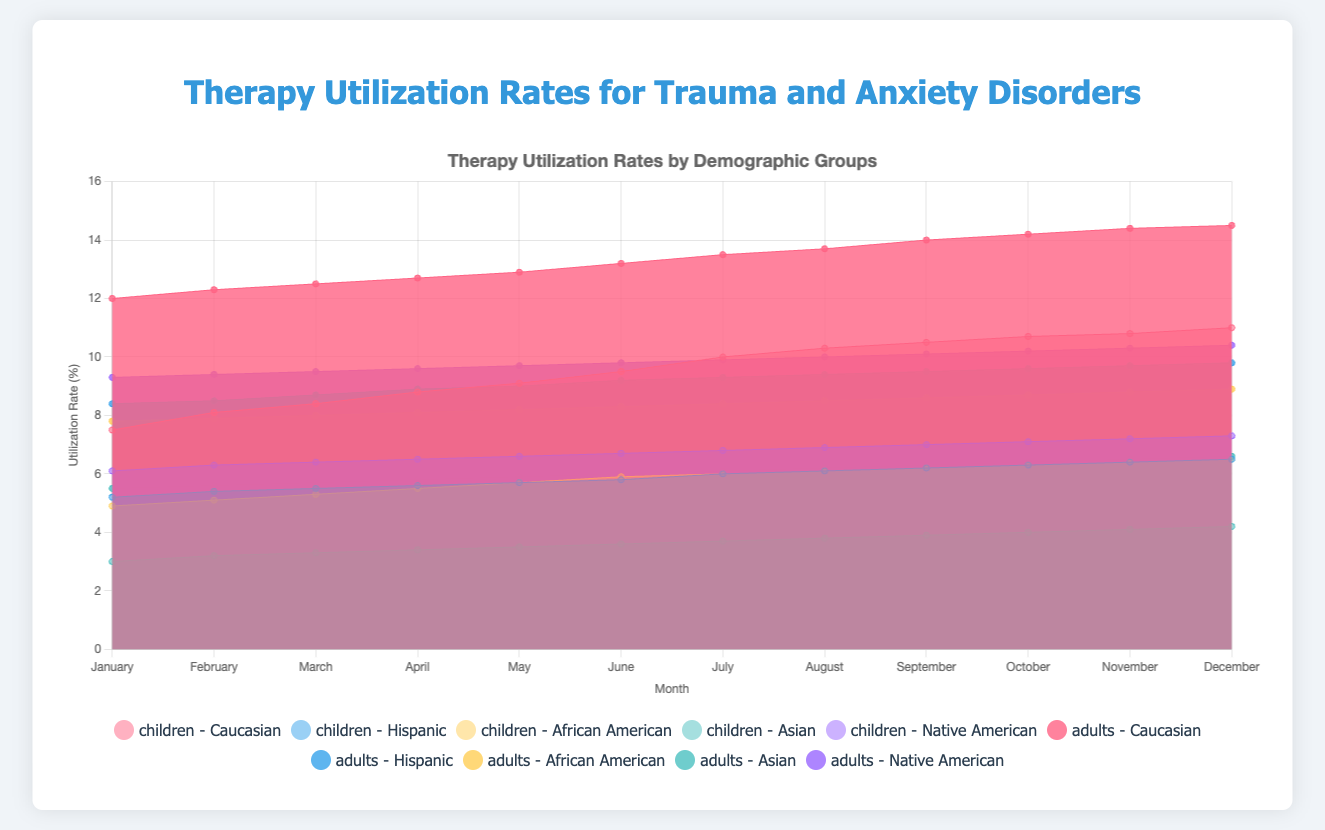What is the title of the figure? The title is usually located at the top of the chart. By looking at the figure, the title can be seen in a prominent position.
Answer: Therapy Utilization Rates for Trauma and Anxiety Disorders Which group has the highest therapy utilization rates for children in December? By checking the highest point in December for children across all demographic groups, one can determine which group has the highest rate. Caucasian children have the highest rate with a utilization rate of 11.0%.
Answer: Caucasian How do the therapy utilization rates of Hispanic adults change from January to December? Observe the trend line for Hispanic adults from January (8.4%) to December (9.8%). There is a gradual increase in therapy utilization rates over the months.
Answer: Incremental increase What is the difference in therapy utilization rates between Caucasian children and African American children in June? Identify the rates for Caucasian children (9.5%) and African American children (5.9%) in June and subtract the smaller rate from the larger rate. The difference is 9.5 - 5.9 = 3.6%.
Answer: 3.6% Which demographic group of adults has the lowest therapy utilization rate in January and what is the rate? Observing the January data for adults across all groups, identify the group with the lowest rate. Asian adults have the lowest therapy utilization rate of 5.5%.
Answer: Asian, 5.5% How does the therapy utilization rate of Native American children compare from January to June? Examine the data points for Native American children from January (6.1%) to June (6.7%). The utilization rate increases gradually over these months.
Answer: Gradual increase What is the average therapy utilization rate for Hispanic children over the year? Sum the monthly rates for Hispanic children (5.2+5.4+5.5+5.6+5.7+5.8+6.0+6.1+6.2+6.3+6.4+6.5 = 70.7) and divide by the number of months (12). The average rate is 70.7/12 ≈ 5.89%.
Answer: 5.89% By how much does the therapy utilization rate for Asian adults increase from January to December? Check the rate in January (5.5%) and compare it with December (6.6%). Calculate the increase as 6.6 - 5.5 = 1.1%.
Answer: 1.1% Which demographic group shows the highest increase in therapy utilization rates for children over the year? By comparing the utilization rates in January and December for all children's groups, calculate the differences. Caucasian children have the highest increase (11.0 - 7.5 = 3.5%).
Answer: Caucasian What is the combined therapy utilization rate for Native American children and adults in November? Add the rates for Native American children (7.2%) and Native American adults (10.3%) in November. The combined rate is 7.2 + 10.3 = 17.5%.
Answer: 17.5% 